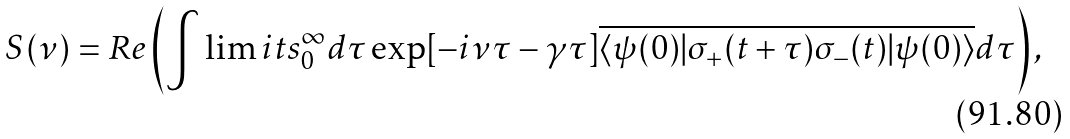Convert formula to latex. <formula><loc_0><loc_0><loc_500><loc_500>S ( \nu ) = R e \left ( \int \lim i t s _ { 0 } ^ { \infty } d \tau \exp [ - i \nu \tau - \gamma \tau ] \overline { \langle \psi ( 0 ) | \sigma _ { + } ( t + \tau ) \sigma _ { - } ( t ) | \psi ( 0 ) \rangle } d \tau \right ) ,</formula> 